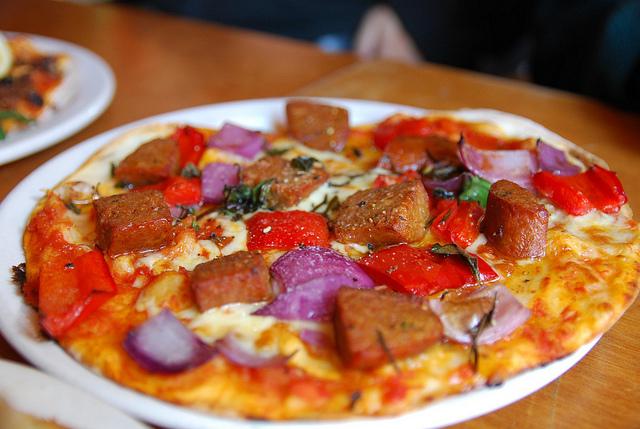Would this taste good?
Quick response, please. Yes. What type of pizza would this be?
Write a very short answer. Sausage pepper and onion. What herb is on the pizza?
Write a very short answer. Basil. What is mainly featured?
Quick response, please. Pizza. Is there anything purple in the picture?
Short answer required. Yes. Is this a meat pizza?
Write a very short answer. Yes. 